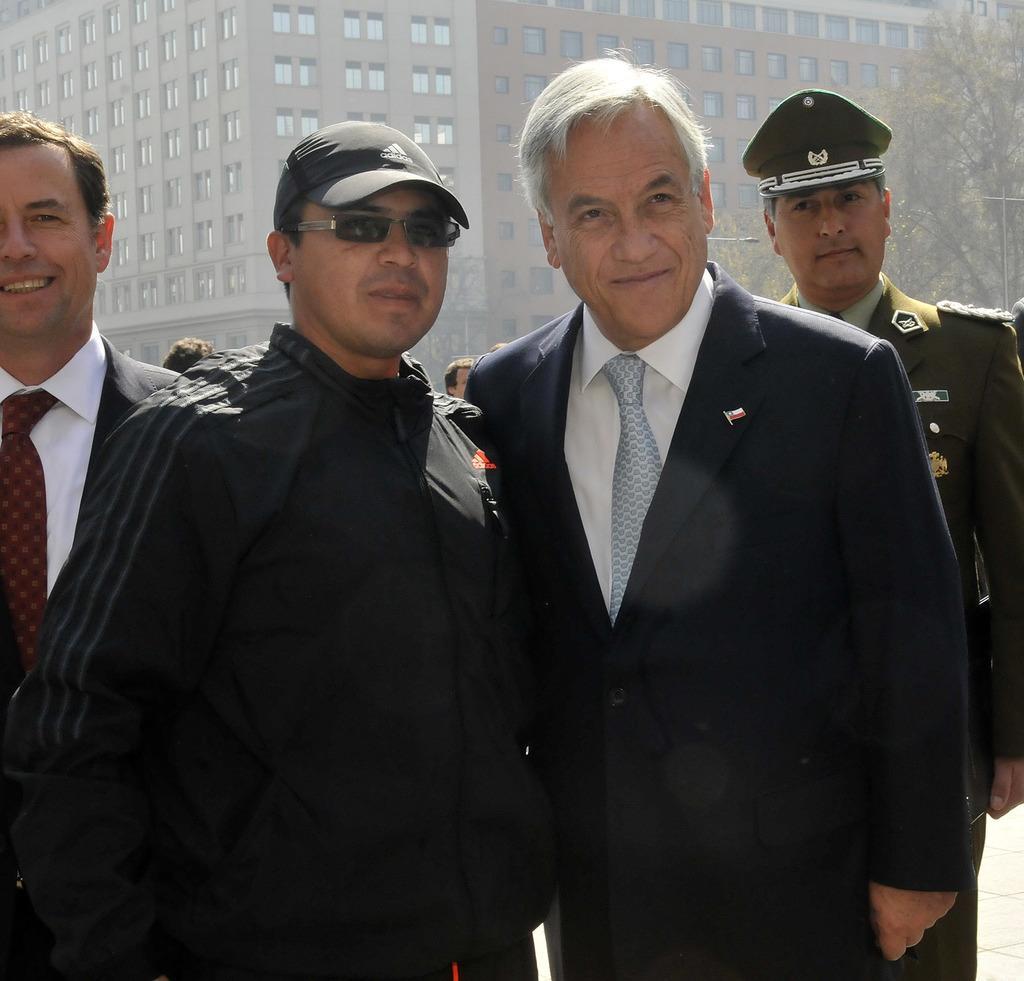Could you give a brief overview of what you see in this image? There are four men standing and smiling, behind these men we can see people. In the background we can see trees, pole, light, building and windows. 